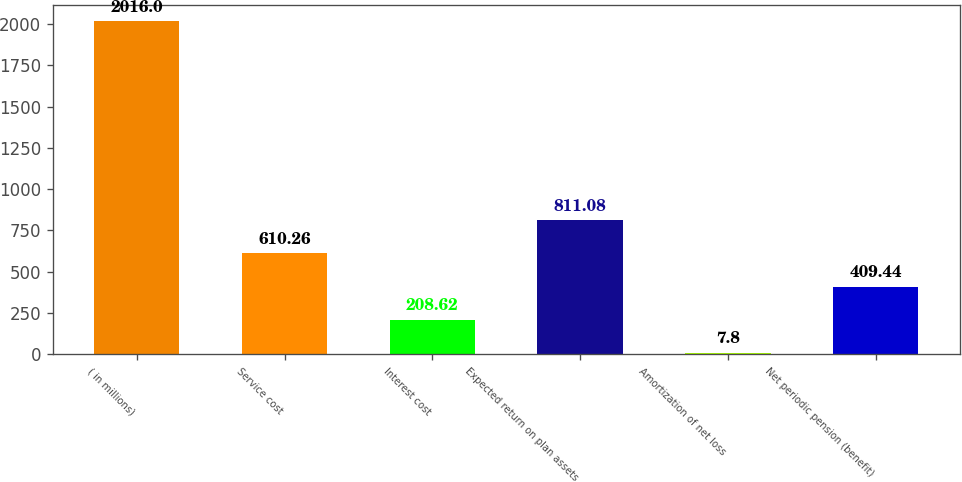<chart> <loc_0><loc_0><loc_500><loc_500><bar_chart><fcel>( in millions)<fcel>Service cost<fcel>Interest cost<fcel>Expected return on plan assets<fcel>Amortization of net loss<fcel>Net periodic pension (benefit)<nl><fcel>2016<fcel>610.26<fcel>208.62<fcel>811.08<fcel>7.8<fcel>409.44<nl></chart> 